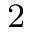Convert formula to latex. <formula><loc_0><loc_0><loc_500><loc_500>^ { 2 }</formula> 